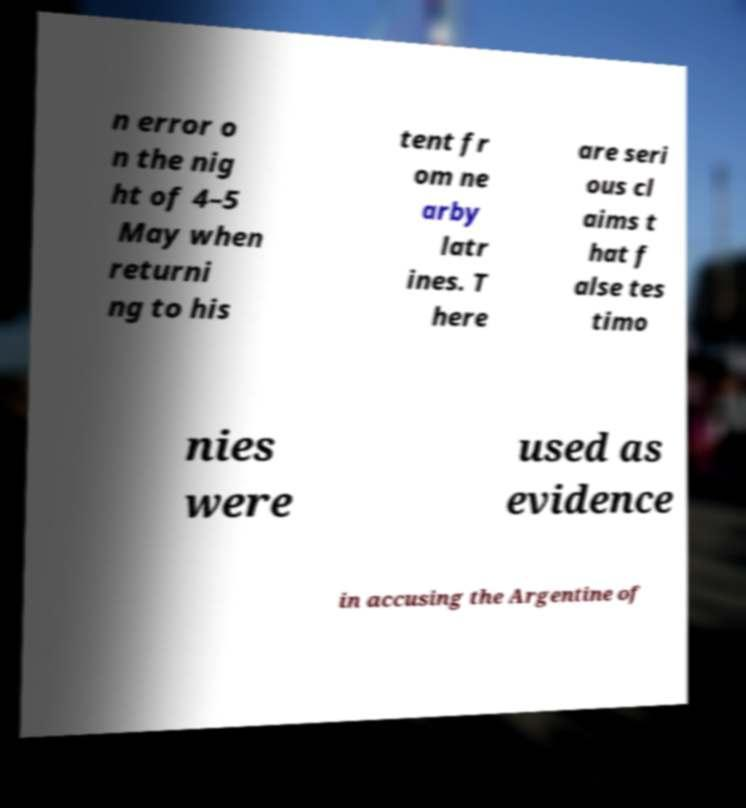There's text embedded in this image that I need extracted. Can you transcribe it verbatim? n error o n the nig ht of 4–5 May when returni ng to his tent fr om ne arby latr ines. T here are seri ous cl aims t hat f alse tes timo nies were used as evidence in accusing the Argentine of 